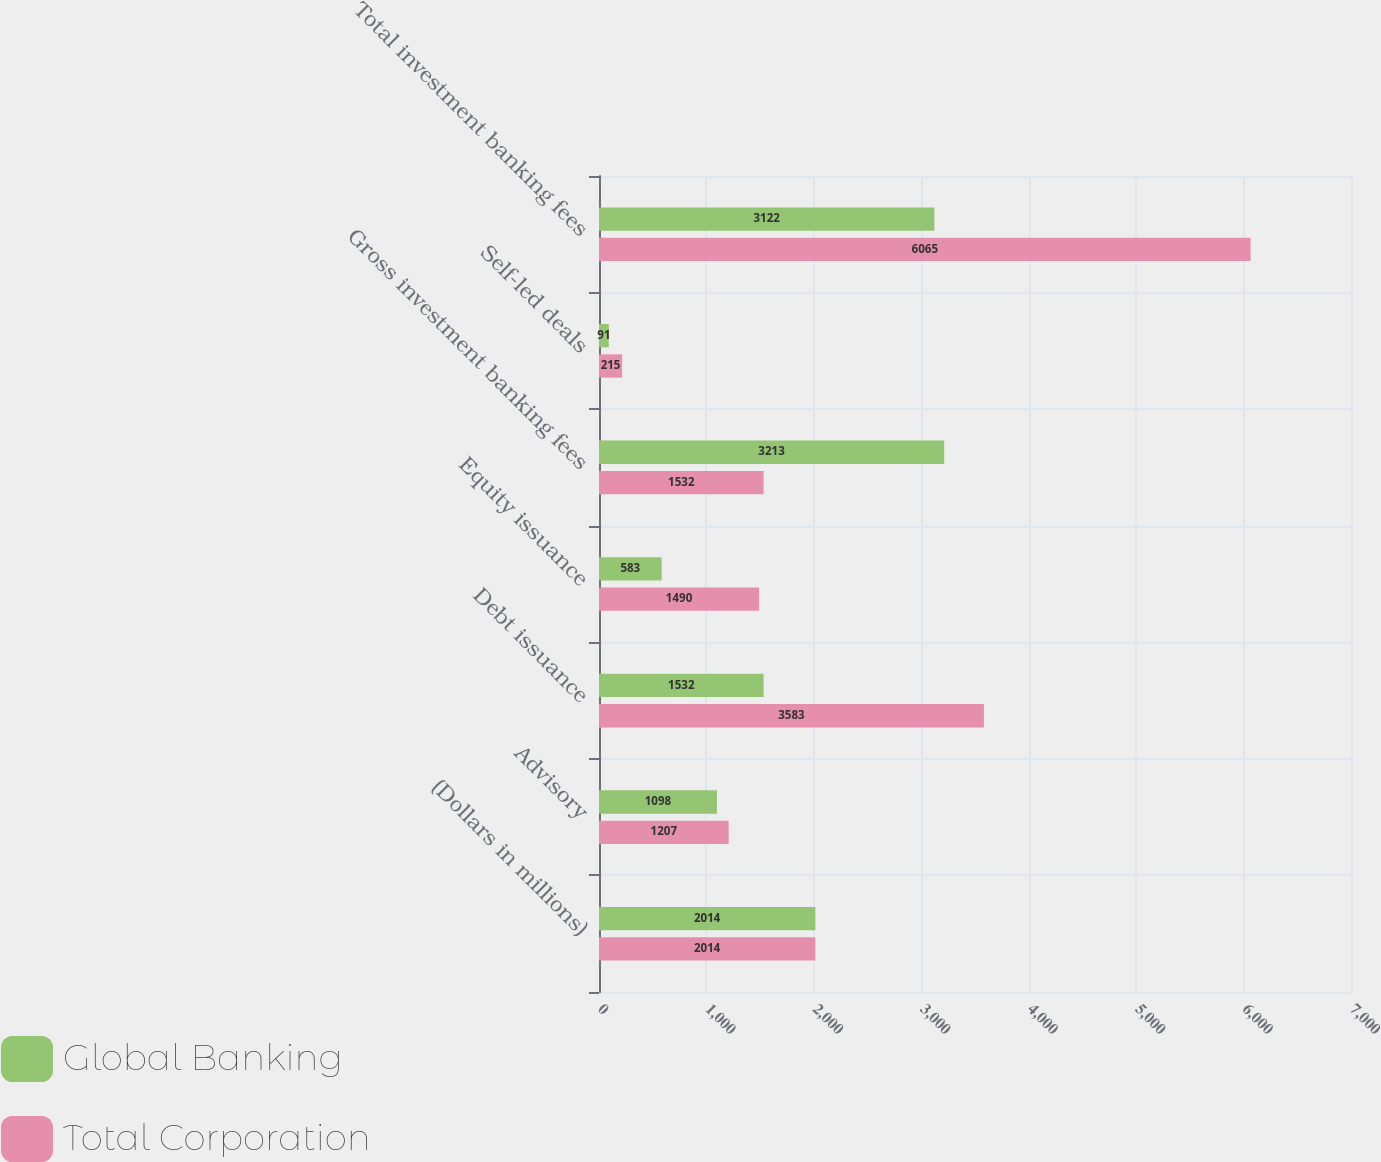<chart> <loc_0><loc_0><loc_500><loc_500><stacked_bar_chart><ecel><fcel>(Dollars in millions)<fcel>Advisory<fcel>Debt issuance<fcel>Equity issuance<fcel>Gross investment banking fees<fcel>Self-led deals<fcel>Total investment banking fees<nl><fcel>Global Banking<fcel>2014<fcel>1098<fcel>1532<fcel>583<fcel>3213<fcel>91<fcel>3122<nl><fcel>Total Corporation<fcel>2014<fcel>1207<fcel>3583<fcel>1490<fcel>1532<fcel>215<fcel>6065<nl></chart> 